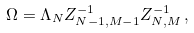Convert formula to latex. <formula><loc_0><loc_0><loc_500><loc_500>\Omega = \Lambda _ { N } Z _ { N { - } 1 , M { - } 1 } ^ { - 1 } Z _ { N , M } ^ { - 1 } \, ,</formula> 